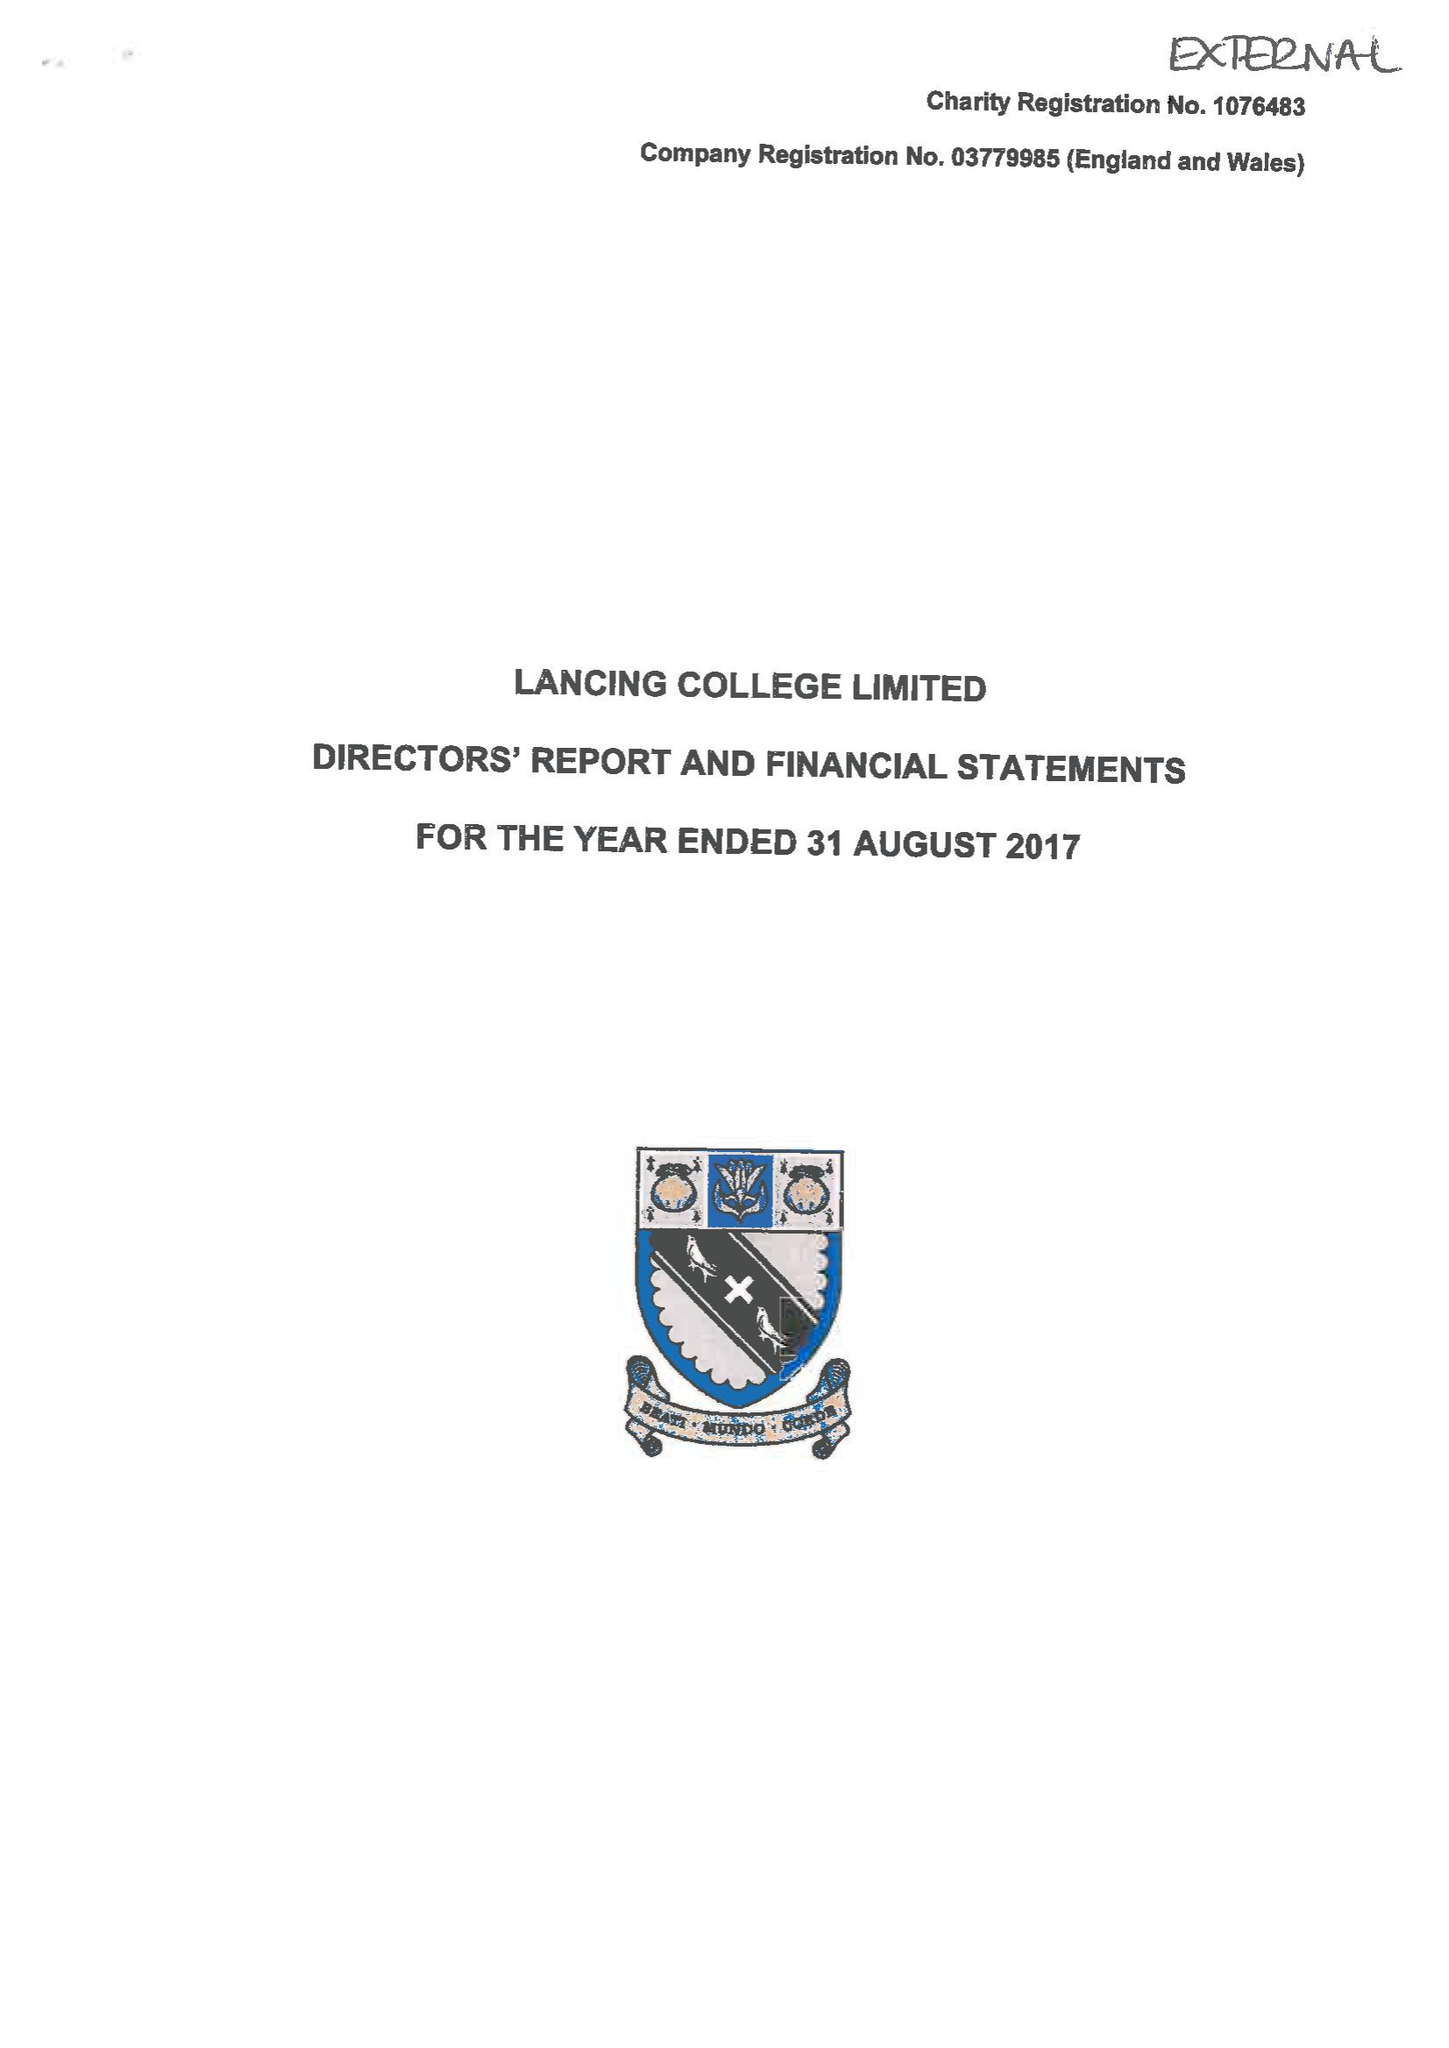What is the value for the address__postcode?
Answer the question using a single word or phrase. BN15 0RW 